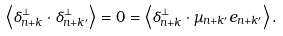Convert formula to latex. <formula><loc_0><loc_0><loc_500><loc_500>\left \langle \delta _ { n + k } ^ { \perp } \cdot \delta _ { n + k ^ { \prime } } ^ { \perp } \right \rangle = 0 = \left \langle \delta _ { n + k } ^ { \perp } \cdot \mu _ { n + k ^ { \prime } } e _ { n + k ^ { \prime } } \right \rangle .</formula> 